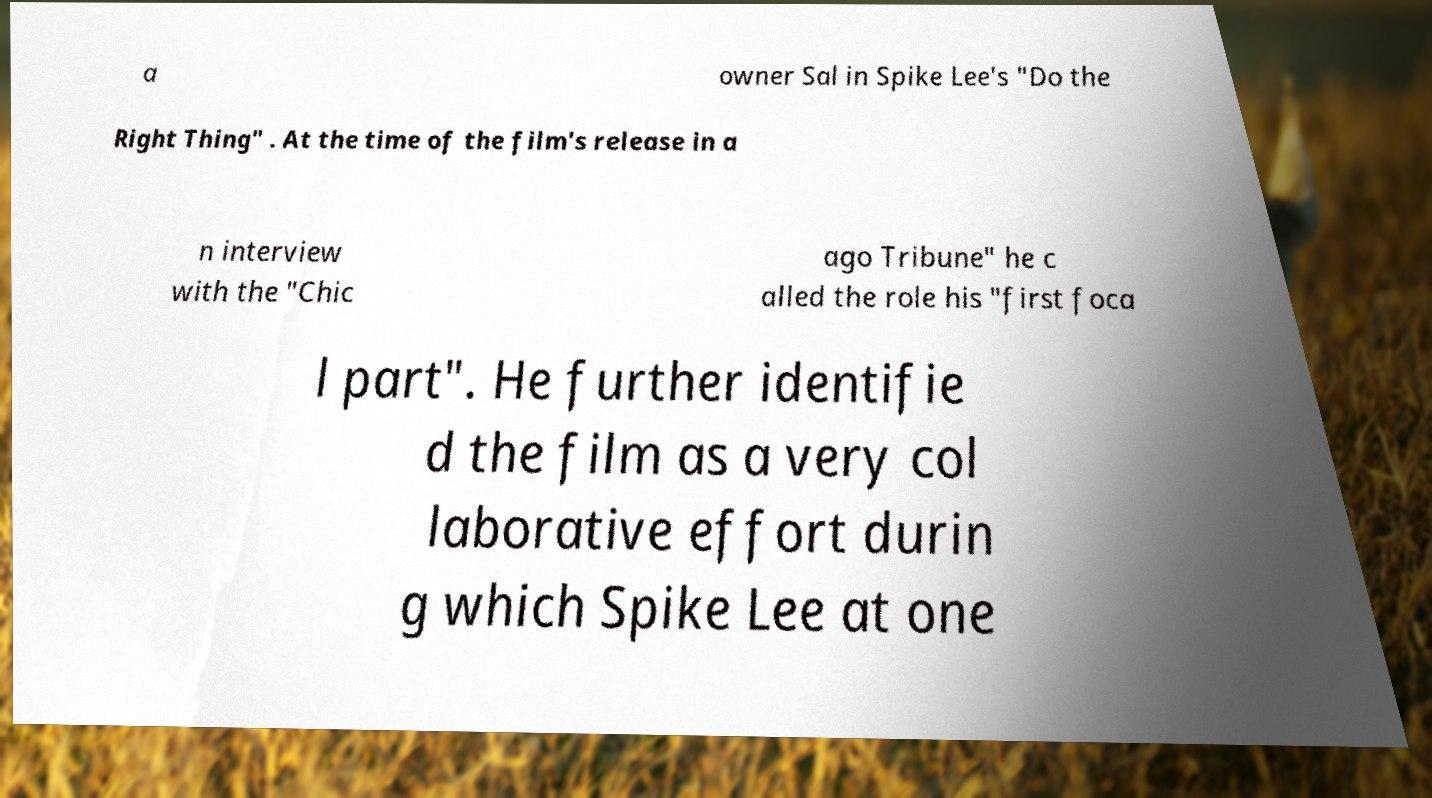For documentation purposes, I need the text within this image transcribed. Could you provide that? a owner Sal in Spike Lee's "Do the Right Thing" . At the time of the film's release in a n interview with the "Chic ago Tribune" he c alled the role his "first foca l part". He further identifie d the film as a very col laborative effort durin g which Spike Lee at one 